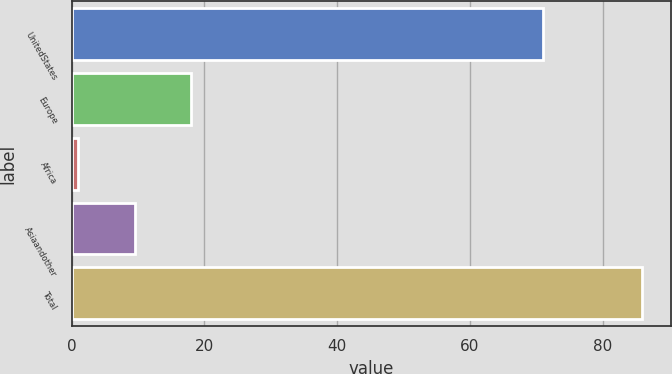Convert chart. <chart><loc_0><loc_0><loc_500><loc_500><bar_chart><fcel>UnitedStates<fcel>Europe<fcel>Africa<fcel>Asiaandother<fcel>Total<nl><fcel>71<fcel>18<fcel>1<fcel>9.5<fcel>86<nl></chart> 